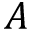<formula> <loc_0><loc_0><loc_500><loc_500>A</formula> 